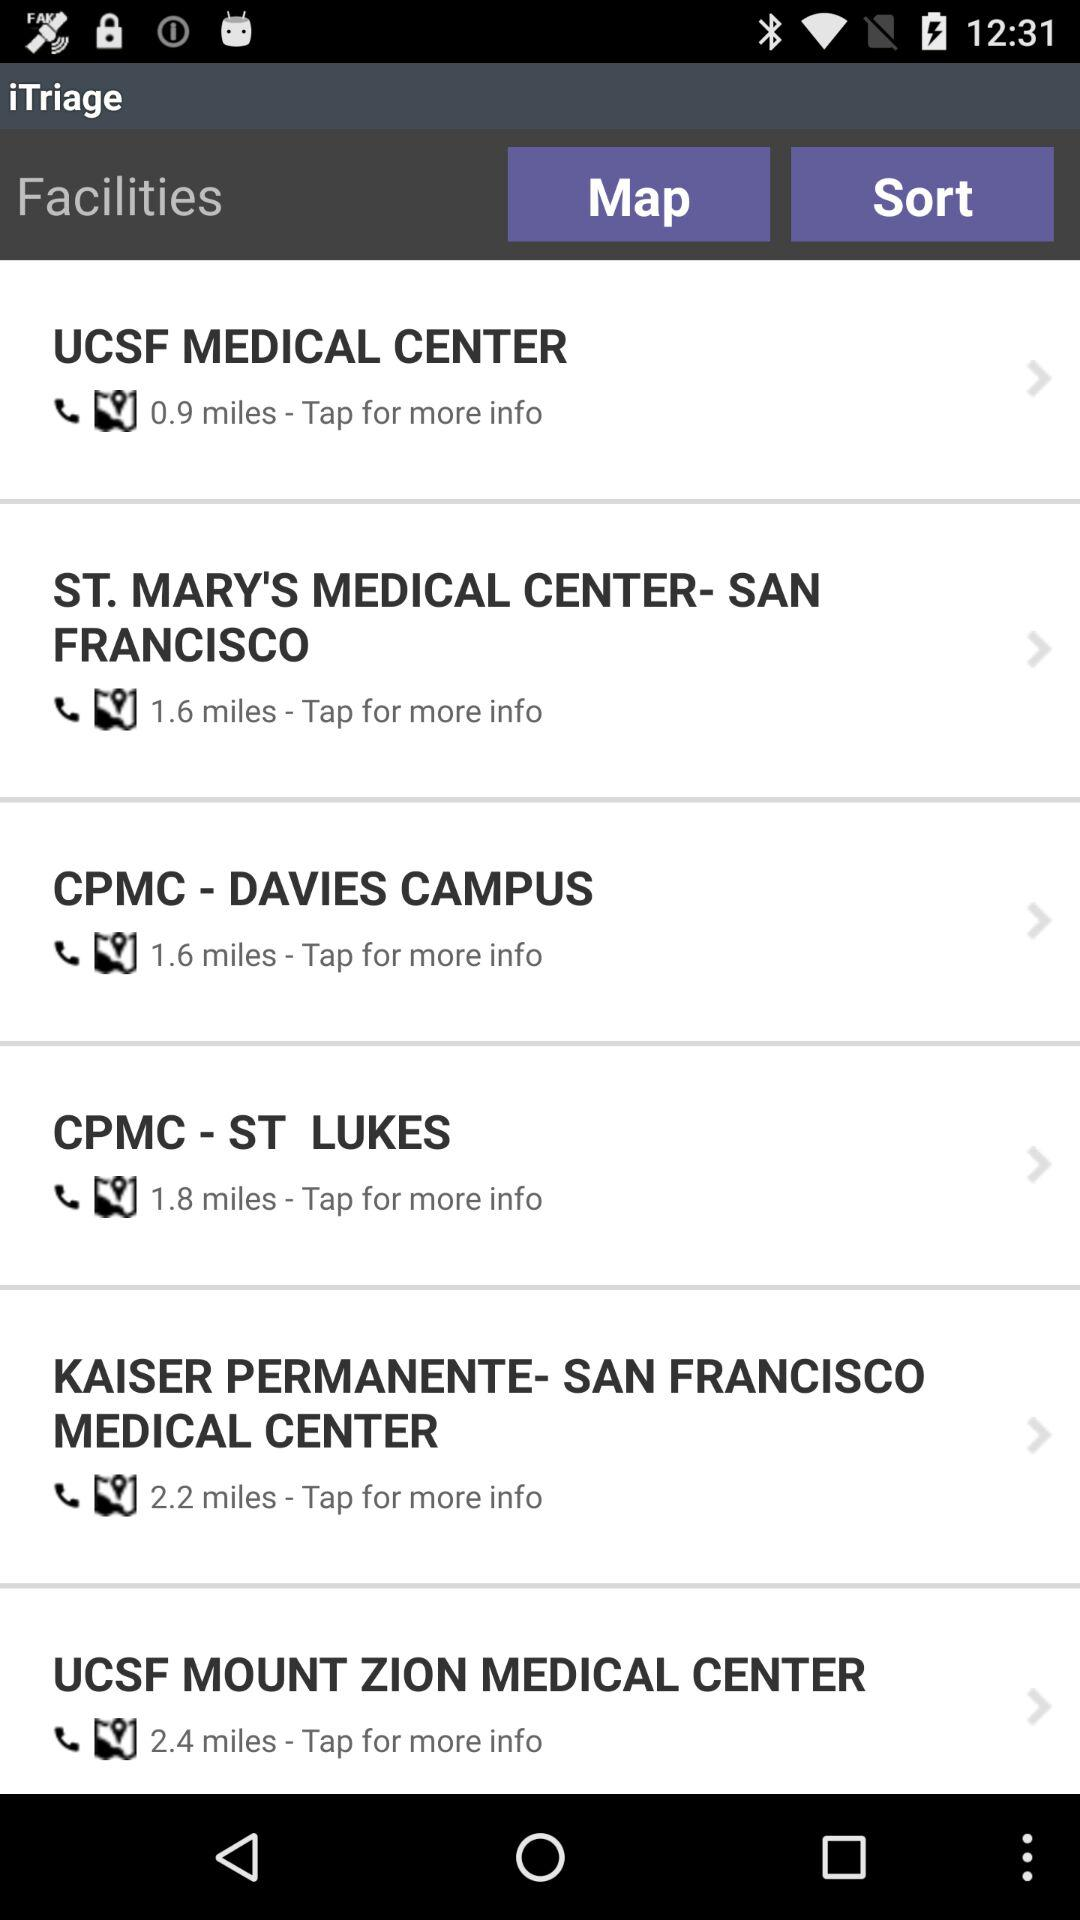What is the distance to the UCSF Medical Center? The distance to the UCSF Medical Center is 0.9 miles. 